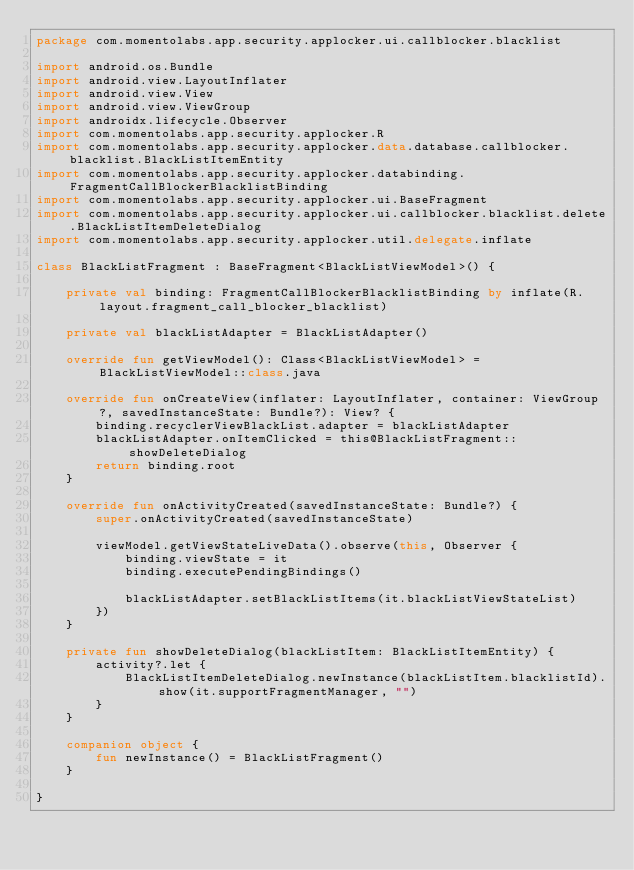<code> <loc_0><loc_0><loc_500><loc_500><_Kotlin_>package com.momentolabs.app.security.applocker.ui.callblocker.blacklist

import android.os.Bundle
import android.view.LayoutInflater
import android.view.View
import android.view.ViewGroup
import androidx.lifecycle.Observer
import com.momentolabs.app.security.applocker.R
import com.momentolabs.app.security.applocker.data.database.callblocker.blacklist.BlackListItemEntity
import com.momentolabs.app.security.applocker.databinding.FragmentCallBlockerBlacklistBinding
import com.momentolabs.app.security.applocker.ui.BaseFragment
import com.momentolabs.app.security.applocker.ui.callblocker.blacklist.delete.BlackListItemDeleteDialog
import com.momentolabs.app.security.applocker.util.delegate.inflate

class BlackListFragment : BaseFragment<BlackListViewModel>() {

    private val binding: FragmentCallBlockerBlacklistBinding by inflate(R.layout.fragment_call_blocker_blacklist)

    private val blackListAdapter = BlackListAdapter()

    override fun getViewModel(): Class<BlackListViewModel> = BlackListViewModel::class.java

    override fun onCreateView(inflater: LayoutInflater, container: ViewGroup?, savedInstanceState: Bundle?): View? {
        binding.recyclerViewBlackList.adapter = blackListAdapter
        blackListAdapter.onItemClicked = this@BlackListFragment::showDeleteDialog
        return binding.root
    }

    override fun onActivityCreated(savedInstanceState: Bundle?) {
        super.onActivityCreated(savedInstanceState)

        viewModel.getViewStateLiveData().observe(this, Observer {
            binding.viewState = it
            binding.executePendingBindings()

            blackListAdapter.setBlackListItems(it.blackListViewStateList)
        })
    }

    private fun showDeleteDialog(blackListItem: BlackListItemEntity) {
        activity?.let {
            BlackListItemDeleteDialog.newInstance(blackListItem.blacklistId).show(it.supportFragmentManager, "")
        }
    }

    companion object {
        fun newInstance() = BlackListFragment()
    }

}</code> 